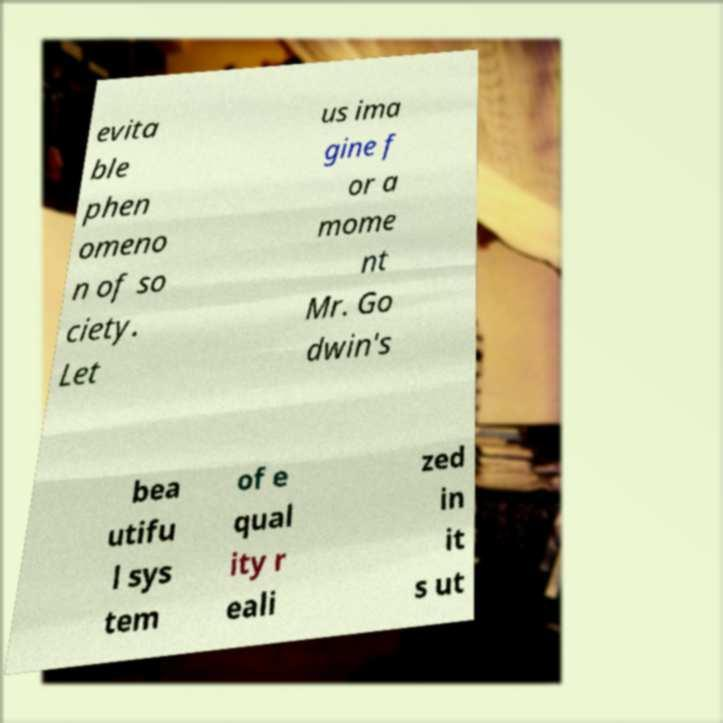I need the written content from this picture converted into text. Can you do that? evita ble phen omeno n of so ciety. Let us ima gine f or a mome nt Mr. Go dwin's bea utifu l sys tem of e qual ity r eali zed in it s ut 